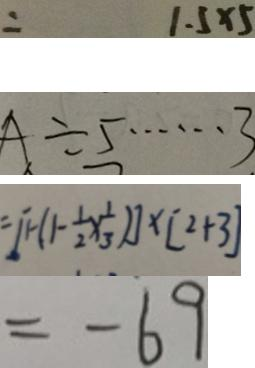Convert formula to latex. <formula><loc_0><loc_0><loc_500><loc_500>= 1 . 5 \times 5 
 A \div 5 \cdots 3 
 = [ 1 - ( 1 - \frac { 1 } { 2 } \times \frac { 1 } { 3 } ) ] \times [ 2 + 3 ] 
 = - 6 9</formula> 